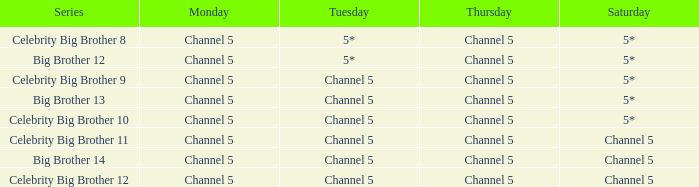On which tuesday is big brother 12 broadcasted? 5*. 